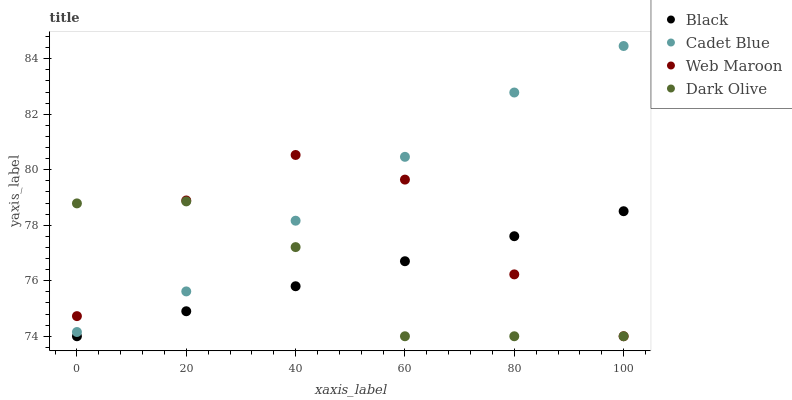Does Dark Olive have the minimum area under the curve?
Answer yes or no. Yes. Does Cadet Blue have the maximum area under the curve?
Answer yes or no. Yes. Does Web Maroon have the minimum area under the curve?
Answer yes or no. No. Does Web Maroon have the maximum area under the curve?
Answer yes or no. No. Is Black the smoothest?
Answer yes or no. Yes. Is Web Maroon the roughest?
Answer yes or no. Yes. Is Cadet Blue the smoothest?
Answer yes or no. No. Is Cadet Blue the roughest?
Answer yes or no. No. Does Dark Olive have the lowest value?
Answer yes or no. Yes. Does Cadet Blue have the lowest value?
Answer yes or no. No. Does Cadet Blue have the highest value?
Answer yes or no. Yes. Does Web Maroon have the highest value?
Answer yes or no. No. Is Black less than Cadet Blue?
Answer yes or no. Yes. Is Cadet Blue greater than Black?
Answer yes or no. Yes. Does Cadet Blue intersect Web Maroon?
Answer yes or no. Yes. Is Cadet Blue less than Web Maroon?
Answer yes or no. No. Is Cadet Blue greater than Web Maroon?
Answer yes or no. No. Does Black intersect Cadet Blue?
Answer yes or no. No. 